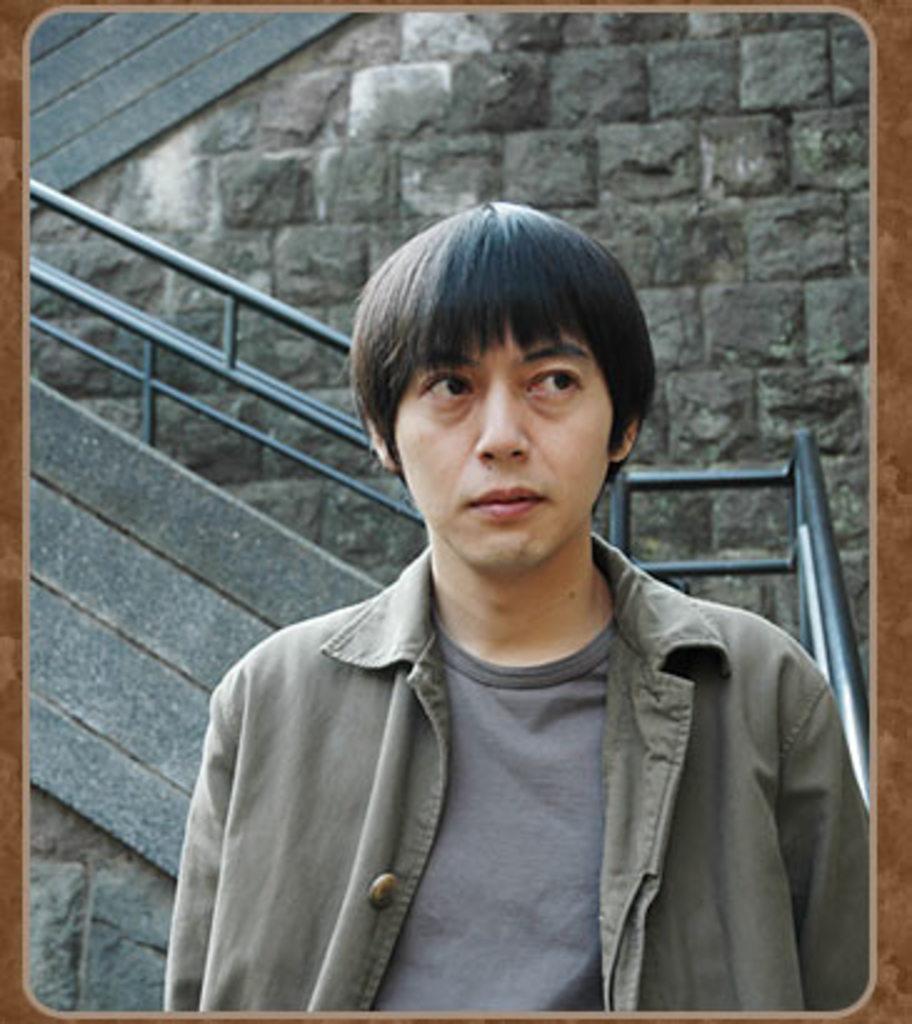In one or two sentences, can you explain what this image depicts? A person is standing and watching towards right. Behind him there is fencing and a stone wall. 